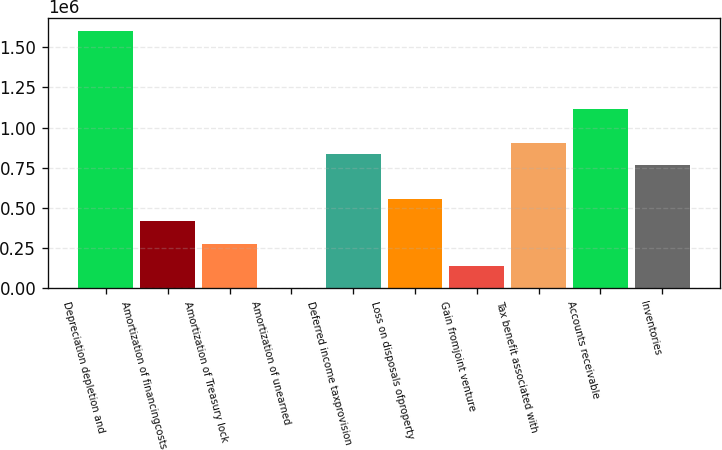Convert chart. <chart><loc_0><loc_0><loc_500><loc_500><bar_chart><fcel>Depreciation depletion and<fcel>Amortization of financingcosts<fcel>Amortization of Treasury lock<fcel>Amortization of unearned<fcel>Deferred income taxprovision<fcel>Loss on disposals ofproperty<fcel>Gain fromjoint venture<fcel>Tax benefit associated with<fcel>Accounts receivable<fcel>Inventories<nl><fcel>1.60151e+06<fcel>417937<fcel>278692<fcel>204<fcel>835669<fcel>557181<fcel>139448<fcel>905291<fcel>1.11416e+06<fcel>766047<nl></chart> 